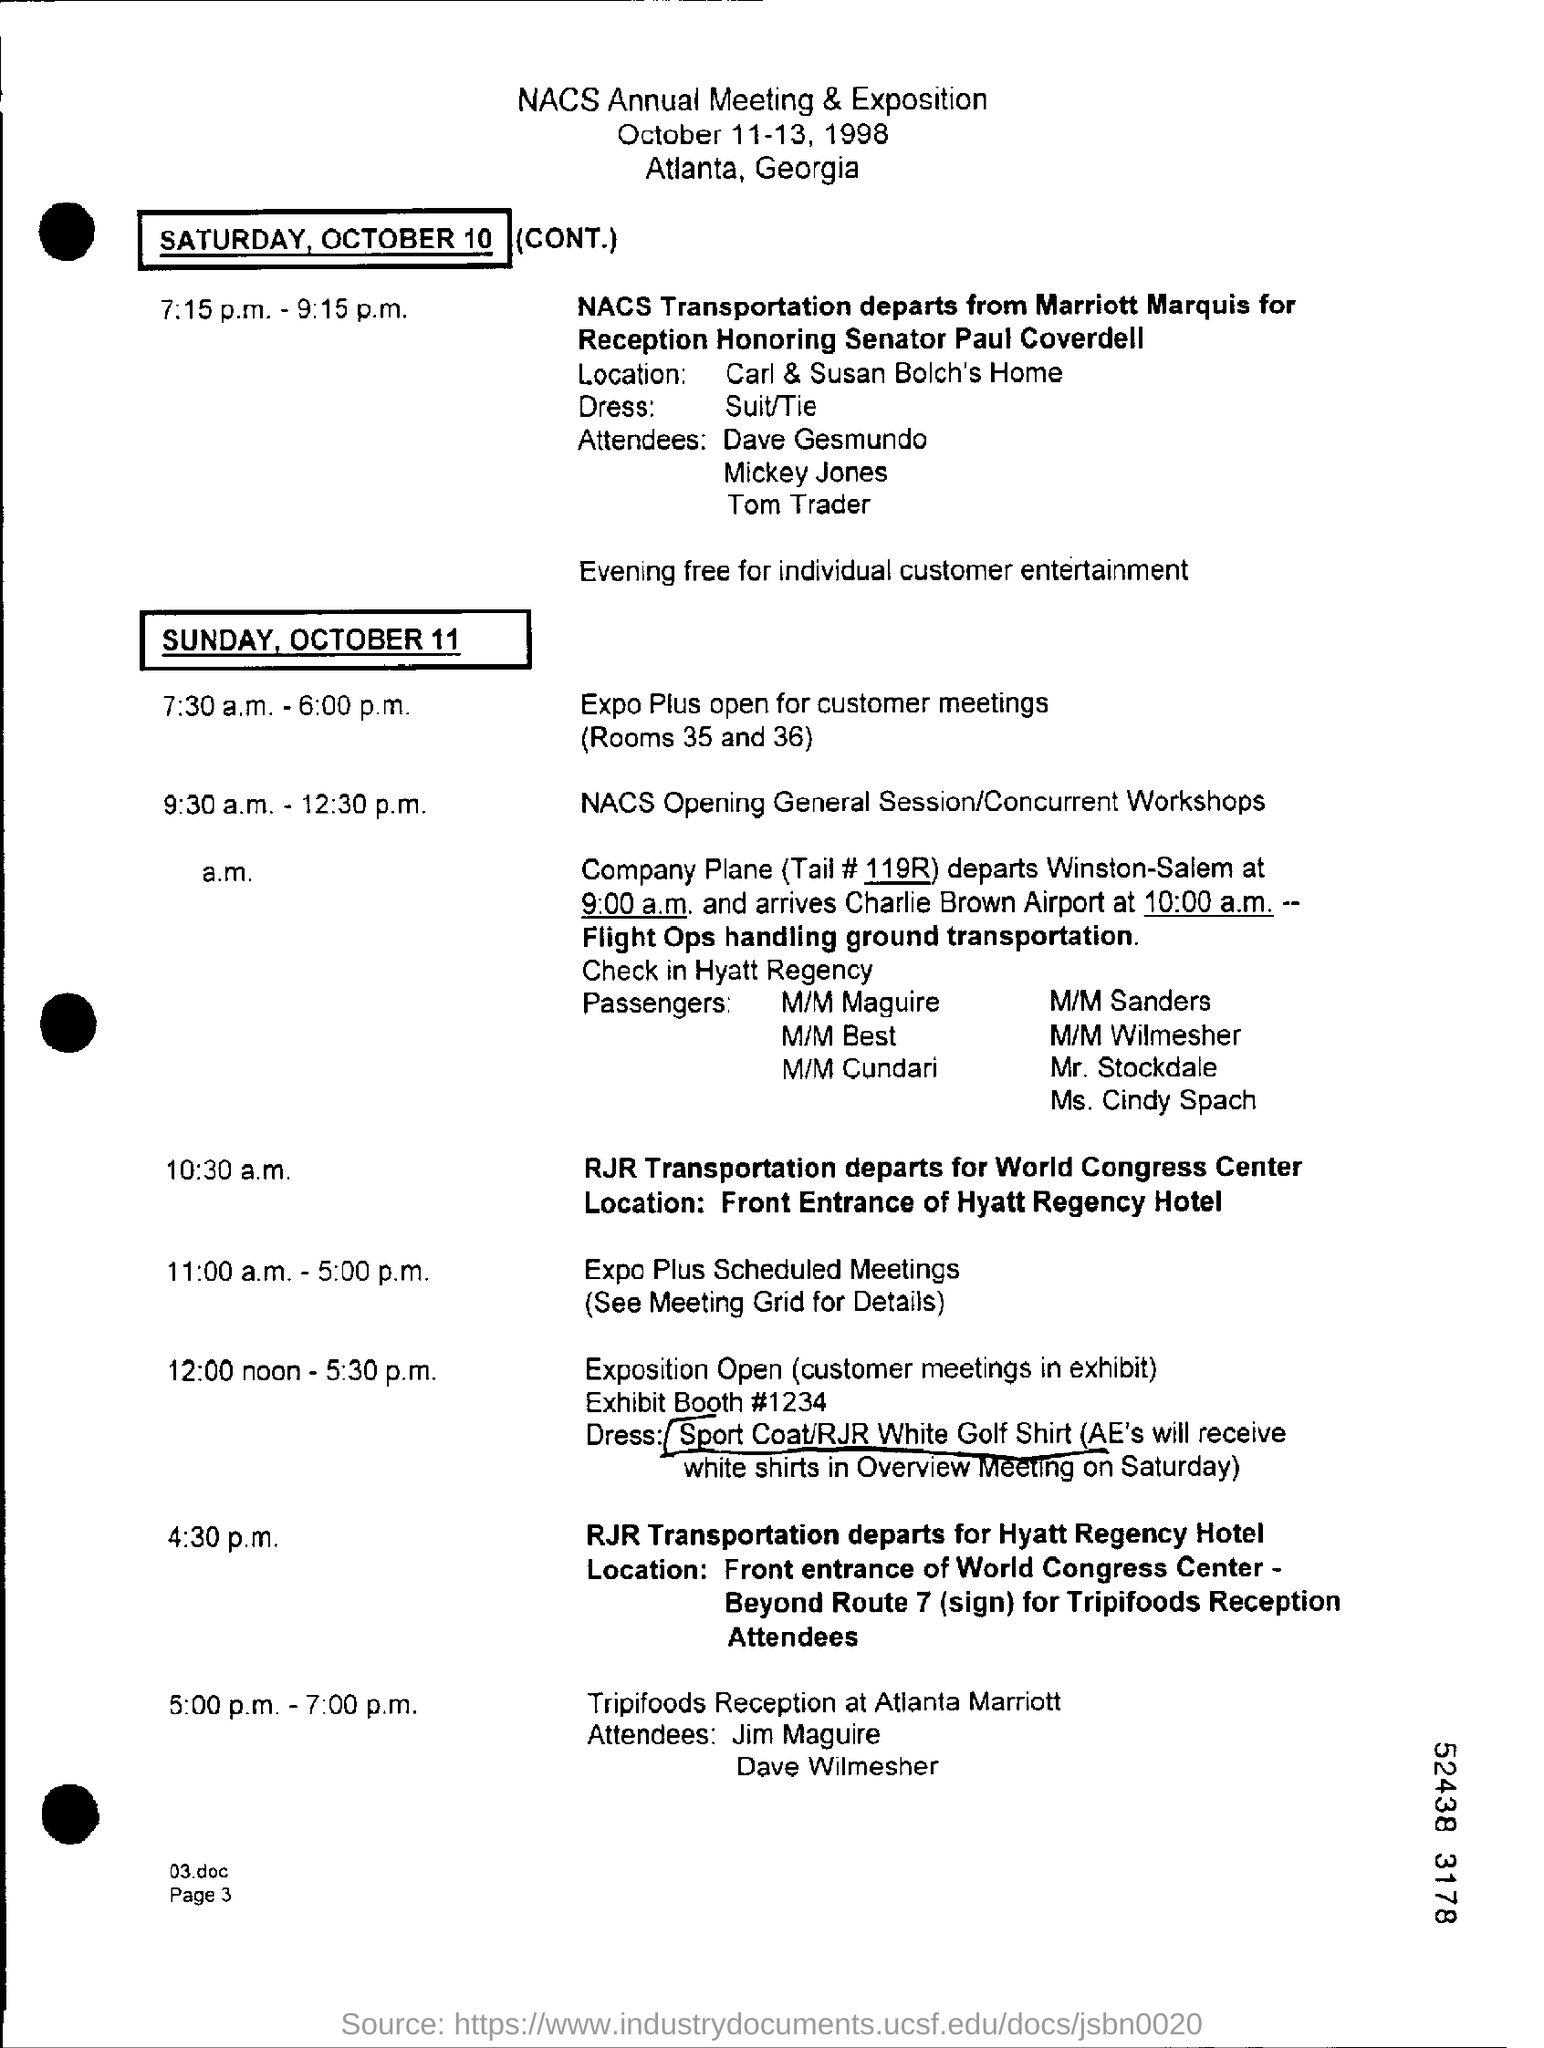Specify some key components in this picture. The exhibit booth number is 1234... I would like to know the value of the tail #, specifically 119R.. The National Association of Convenience Stores (NACS) annual meeting and exposition will take place on October 11-13, 1998. Rooms 35 and 36 are scheduled for the Expo and will also be available for customer meetings. The NACS annual meeting and exposition is taking place in Atlanta, Georgia. 